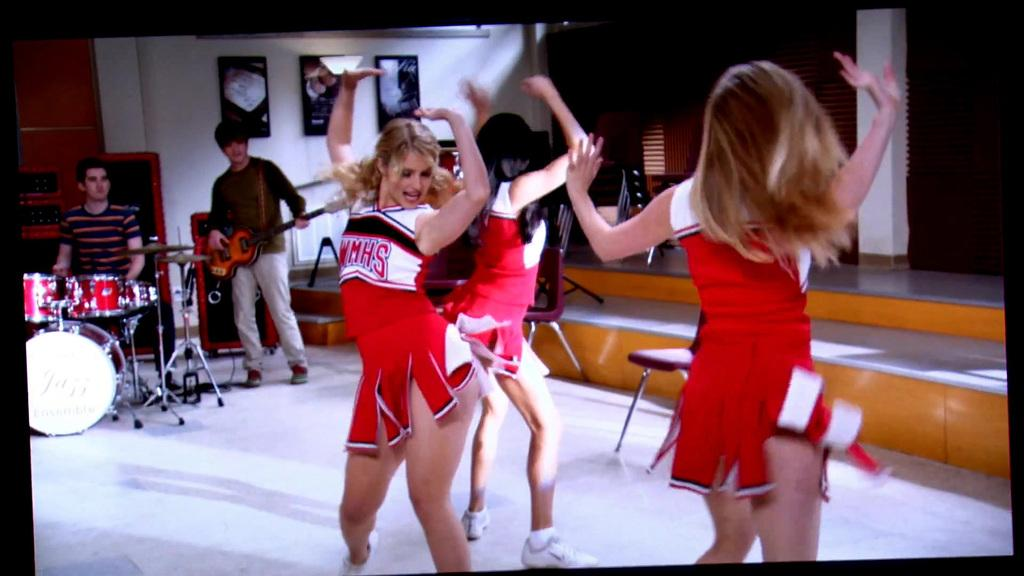<image>
Share a concise interpretation of the image provided. The three cheerleaders dancing together have the letters WMHS on their tops. 